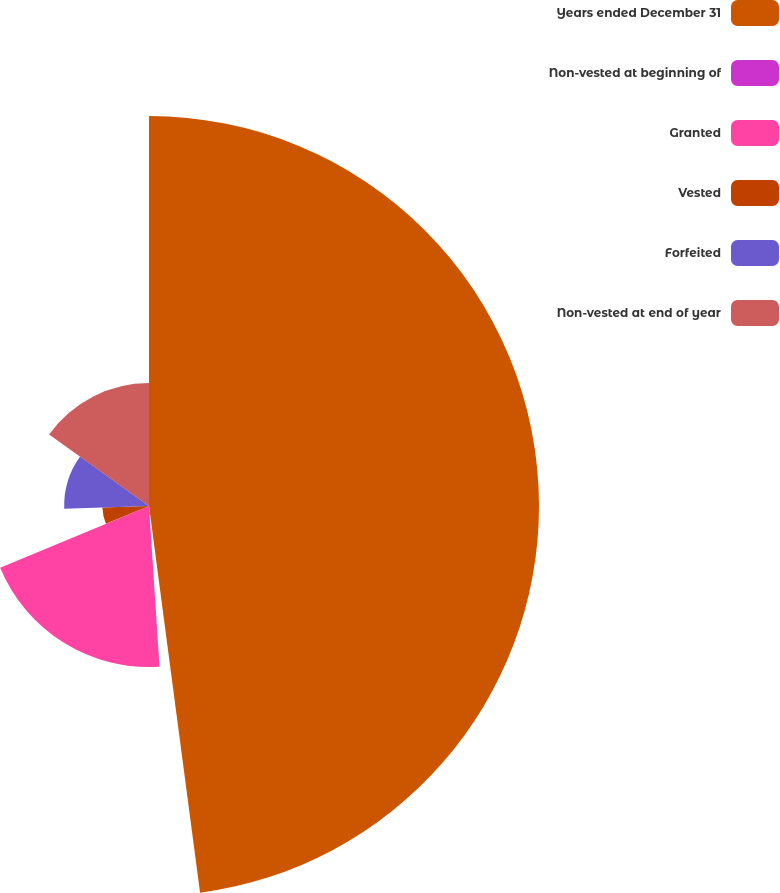<chart> <loc_0><loc_0><loc_500><loc_500><pie_chart><fcel>Years ended December 31<fcel>Non-vested at beginning of<fcel>Granted<fcel>Vested<fcel>Forfeited<fcel>Non-vested at end of year<nl><fcel>47.91%<fcel>1.05%<fcel>19.79%<fcel>5.73%<fcel>10.42%<fcel>15.1%<nl></chart> 